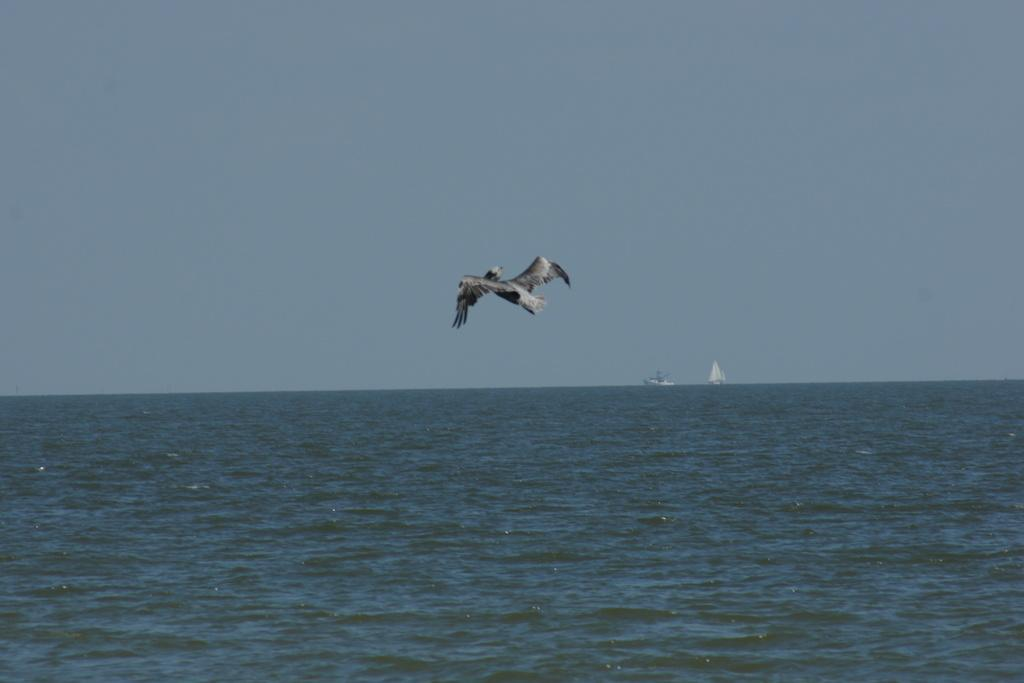What is in the water in the image? There are ships in the water in the image. What else can be seen in the image besides the ships? A bird is flying over the water, and the sky is visible in the image. Where are the beds located in the image? There are no beds present in the image; it features ships in the water, a flying bird, and the sky. What type of flame can be seen on the bird in the image? There is no flame present on the bird in the image; it is simply a bird flying over the water. 